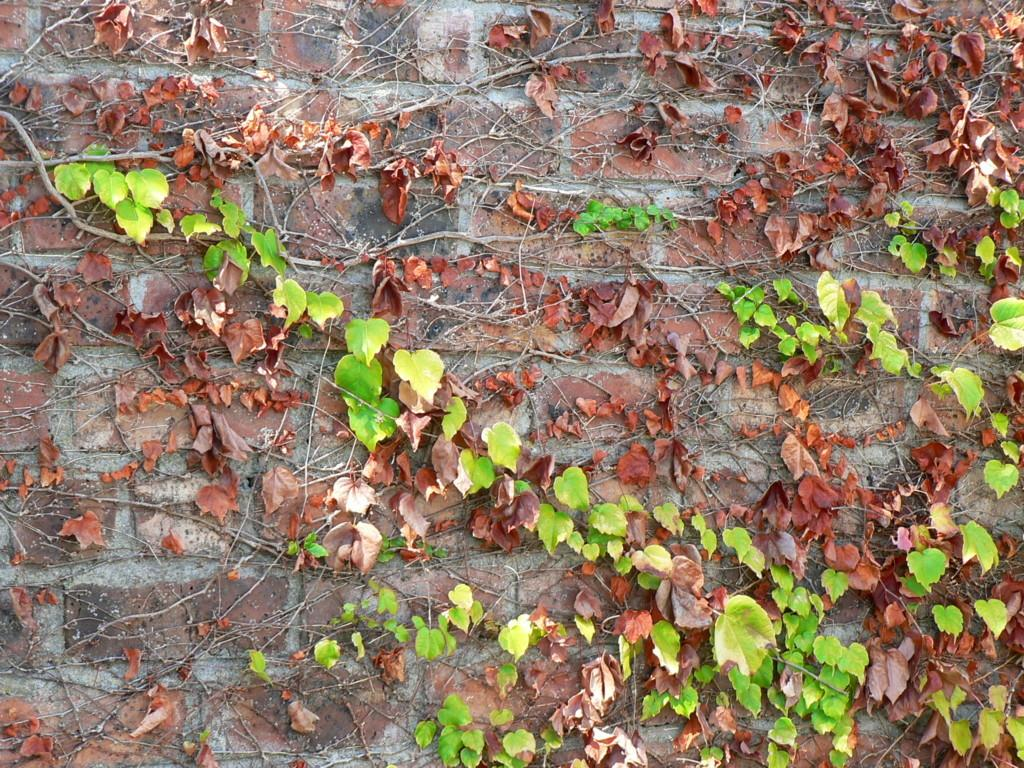What type of vegetation can be seen on the brick wall in the image? There are green and dry vines on a brick wall in the image. What color are the leaves in the center of the image? The leaves in the center of the image are green. How many scissors can be seen in the image? There are no scissors present in the image. What type of town is depicted in the image? The image does not depict a town; it features vines on a brick wall and green leaves. 